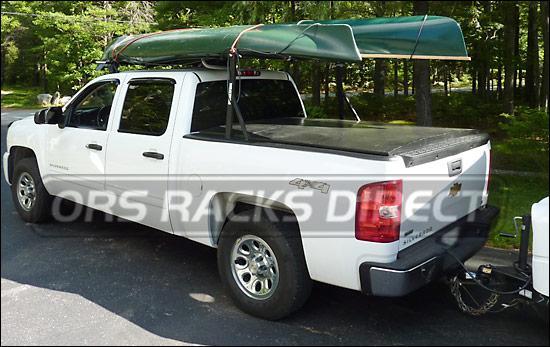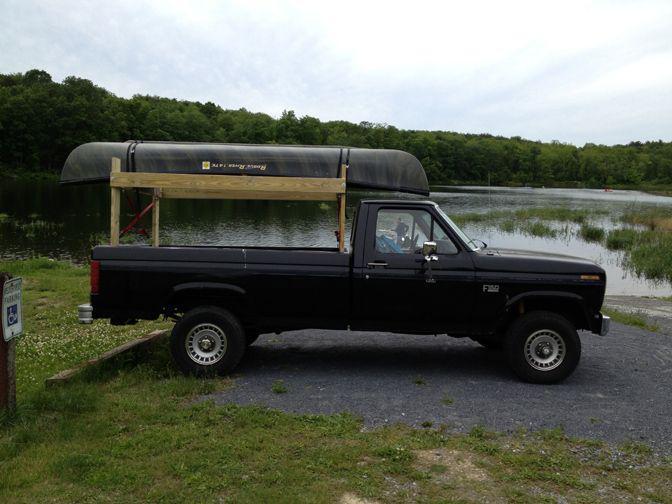The first image is the image on the left, the second image is the image on the right. Considering the images on both sides, is "The left image contains one red truck." valid? Answer yes or no. No. The first image is the image on the left, the second image is the image on the right. For the images shown, is this caption "In one image, a pickup truck near a body of water has one canoe loaded on a roof rack, while a second image shows a pickup truck near a green woody area with two canoes loaded overhead." true? Answer yes or no. Yes. 